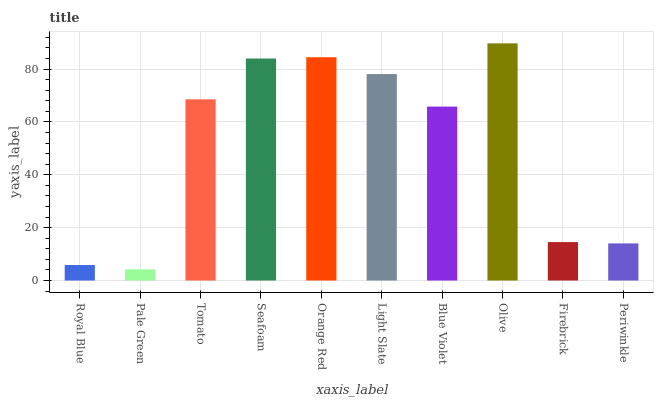Is Pale Green the minimum?
Answer yes or no. Yes. Is Olive the maximum?
Answer yes or no. Yes. Is Tomato the minimum?
Answer yes or no. No. Is Tomato the maximum?
Answer yes or no. No. Is Tomato greater than Pale Green?
Answer yes or no. Yes. Is Pale Green less than Tomato?
Answer yes or no. Yes. Is Pale Green greater than Tomato?
Answer yes or no. No. Is Tomato less than Pale Green?
Answer yes or no. No. Is Tomato the high median?
Answer yes or no. Yes. Is Blue Violet the low median?
Answer yes or no. Yes. Is Seafoam the high median?
Answer yes or no. No. Is Tomato the low median?
Answer yes or no. No. 